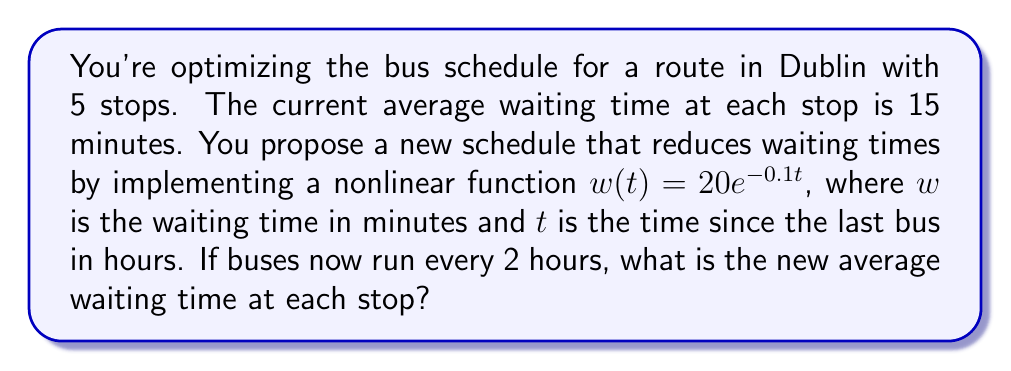Give your solution to this math problem. Let's approach this step-by-step:

1) The given nonlinear function for waiting time is:
   $$w(t) = 20e^{-0.1t}$$

2) We need to find the average waiting time over the 2-hour period between buses.

3) To calculate the average, we need to integrate the function over the 2-hour period and divide by the total time:

   $$\text{Average waiting time} = \frac{1}{2} \int_0^2 20e^{-0.1t} dt$$

4) Let's solve this integral:
   $$\begin{align}
   \frac{1}{2} \int_0^2 20e^{-0.1t} dt &= 10 \int_0^2 e^{-0.1t} dt \\
   &= 10 \left[ -10e^{-0.1t} \right]_0^2 \\
   &= 10 \left[ (-10e^{-0.2}) - (-10e^0) \right] \\
   &= 10 \left[ -10(0.8187) + 10 \right] \\
   &= 10 [1.813] \\
   &= 18.13
   \end{align}$$

5) Therefore, the new average waiting time at each stop is approximately 18.13 minutes.
Answer: 18.13 minutes 